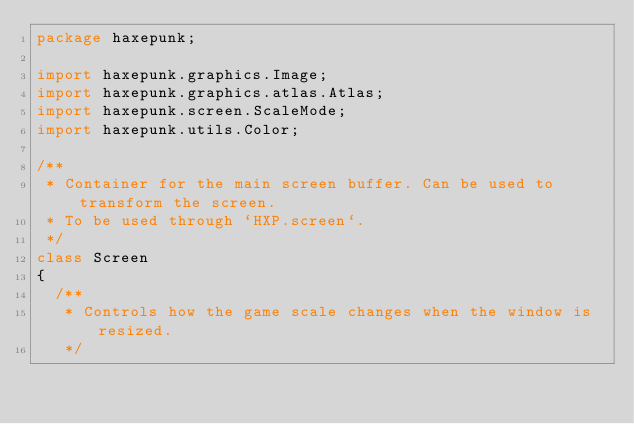<code> <loc_0><loc_0><loc_500><loc_500><_Haxe_>package haxepunk;

import haxepunk.graphics.Image;
import haxepunk.graphics.atlas.Atlas;
import haxepunk.screen.ScaleMode;
import haxepunk.utils.Color;

/**
 * Container for the main screen buffer. Can be used to transform the screen.
 * To be used through `HXP.screen`.
 */
class Screen
{
	/**
	 * Controls how the game scale changes when the window is resized.
	 */</code> 